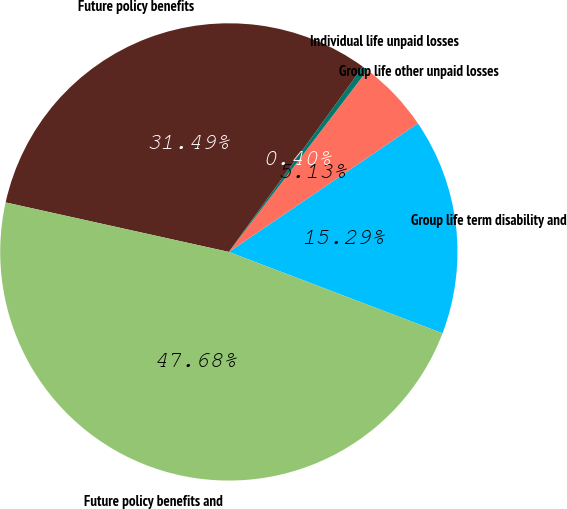Convert chart to OTSL. <chart><loc_0><loc_0><loc_500><loc_500><pie_chart><fcel>Group life term disability and<fcel>Group life other unpaid losses<fcel>Individual life unpaid losses<fcel>Future policy benefits<fcel>Future policy benefits and<nl><fcel>15.29%<fcel>5.13%<fcel>0.4%<fcel>31.49%<fcel>47.68%<nl></chart> 